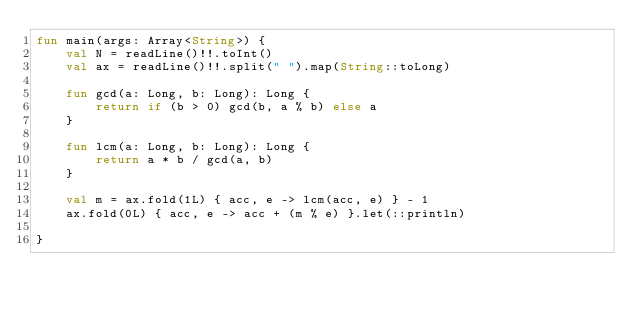<code> <loc_0><loc_0><loc_500><loc_500><_Kotlin_>fun main(args: Array<String>) {
    val N = readLine()!!.toInt()
    val ax = readLine()!!.split(" ").map(String::toLong)

    fun gcd(a: Long, b: Long): Long {
        return if (b > 0) gcd(b, a % b) else a
    }

    fun lcm(a: Long, b: Long): Long {
        return a * b / gcd(a, b)
    }

    val m = ax.fold(1L) { acc, e -> lcm(acc, e) } - 1
    ax.fold(0L) { acc, e -> acc + (m % e) }.let(::println)

}
</code> 